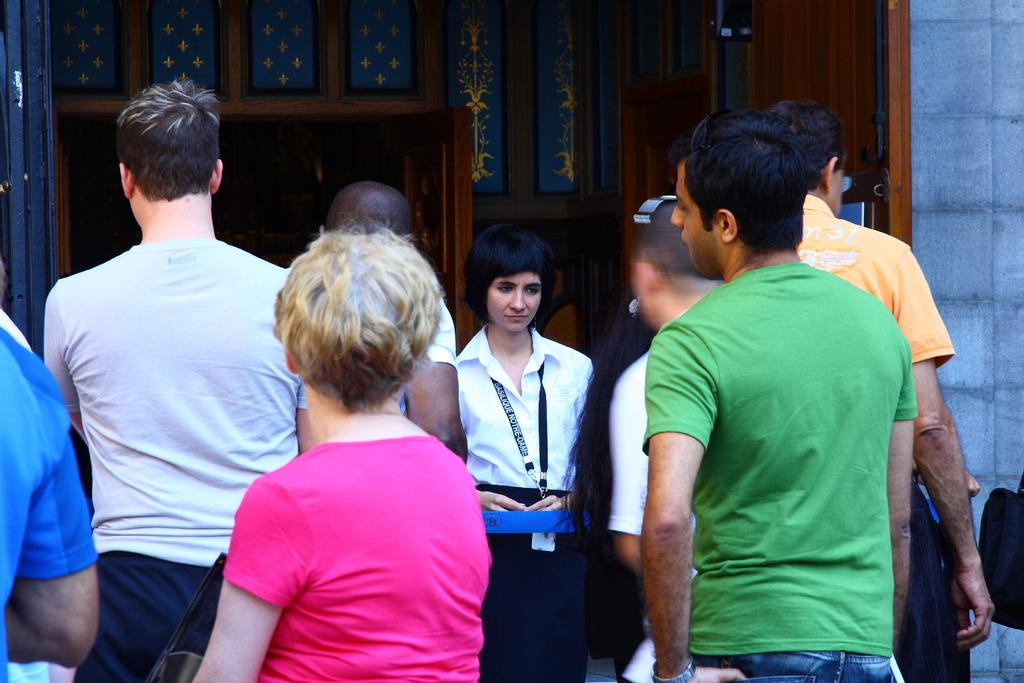What can be seen at the bottom of the image? There are persons in different color dresses at the bottom of the image. What is visible in the background of the image? There is a building and a wall in the background of the image. Can you describe the building in the background? The building in the background has wooden doors. How many apples are being held by the persons in the image? There is no mention of apples in the image, so it cannot be determined how many apples are being held. 